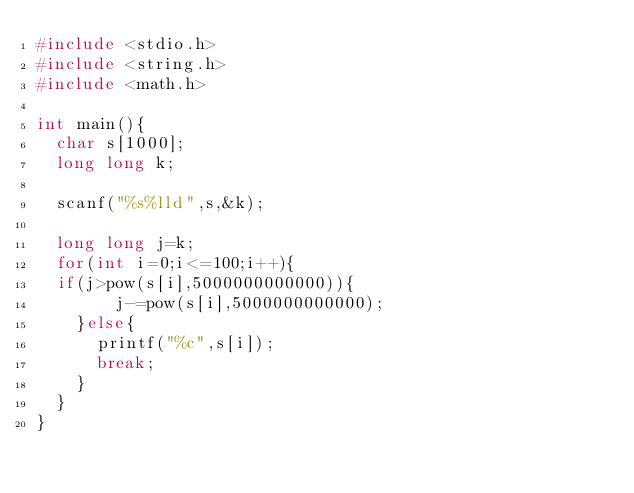Convert code to text. <code><loc_0><loc_0><loc_500><loc_500><_C_>#include <stdio.h>
#include <string.h>
#include <math.h>

int main(){
  char s[1000];
  long long k;

  scanf("%s%lld",s,&k);
  
  long long j=k;
  for(int i=0;i<=100;i++){
	if(j>pow(s[i],5000000000000)){
      	j-=pow(s[i],5000000000000);
    }else{
      printf("%c",s[i]);
      break;
    }
  }
}
</code> 